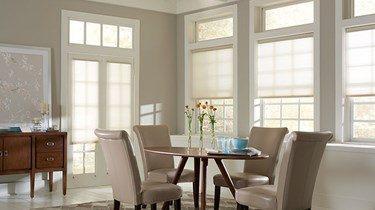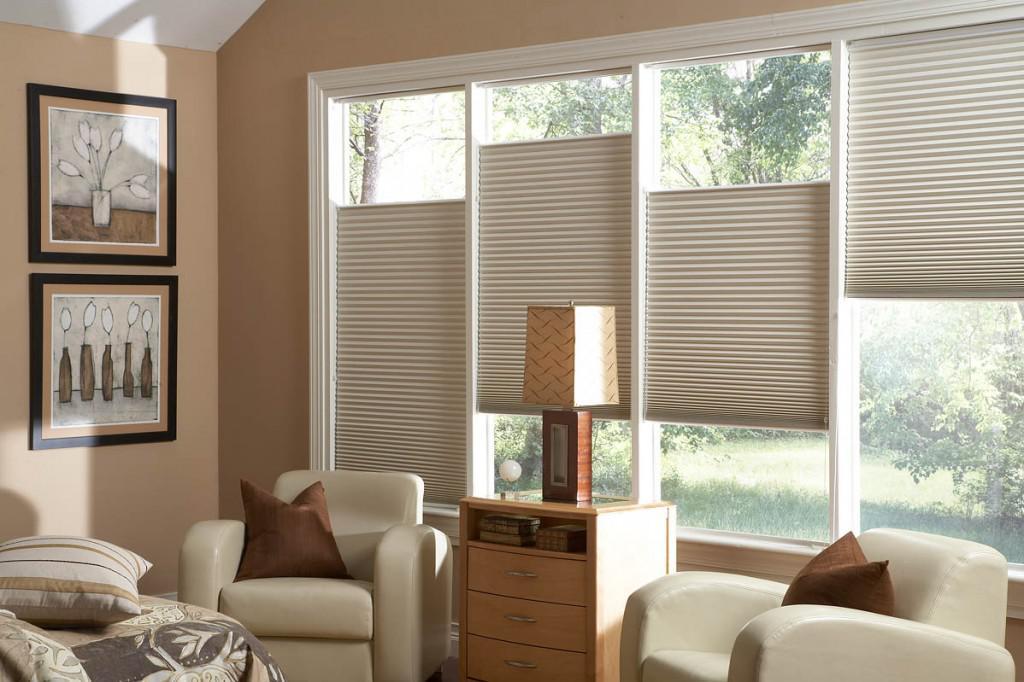The first image is the image on the left, the second image is the image on the right. Evaluate the accuracy of this statement regarding the images: "There are buildings visible through the windows.". Is it true? Answer yes or no. No. The first image is the image on the left, the second image is the image on the right. Examine the images to the left and right. Is the description "One image shows a tufted couch in front of a wide paned window on the left and a narrower window on the right, all with gray shades that don't cover the window tops." accurate? Answer yes or no. No. 